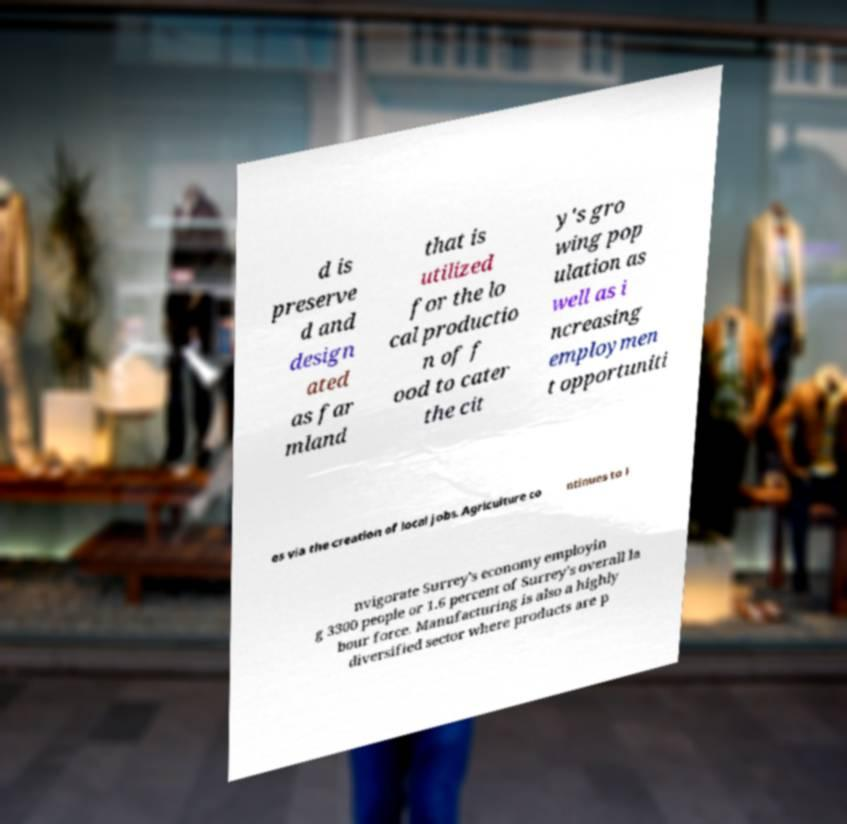I need the written content from this picture converted into text. Can you do that? d is preserve d and design ated as far mland that is utilized for the lo cal productio n of f ood to cater the cit y's gro wing pop ulation as well as i ncreasing employmen t opportuniti es via the creation of local jobs. Agriculture co ntinues to i nvigorate Surrey's economy employin g 3300 people or 1.6 percent of Surrey's overall la bour force. Manufacturing is also a highly diversified sector where products are p 